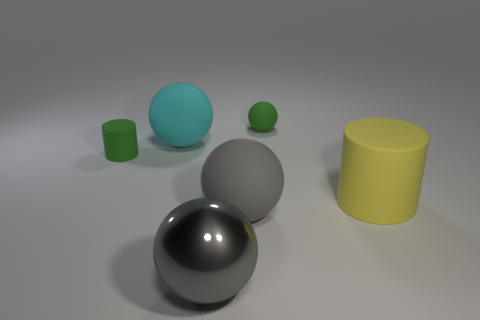What is the shape of the large matte thing that is left of the yellow matte cylinder and in front of the cyan rubber object?
Give a very brief answer. Sphere. There is a large sphere that is behind the cylinder on the left side of the green matte object that is behind the cyan sphere; what color is it?
Make the answer very short. Cyan. Are there fewer metal balls left of the cyan sphere than large rubber balls?
Provide a short and direct response. Yes. There is a big rubber object that is behind the large yellow object; does it have the same shape as the small matte object that is right of the large cyan matte ball?
Your answer should be very brief. Yes. What number of objects are rubber objects that are behind the big cylinder or green matte cylinders?
Your response must be concise. 3. There is a small thing that is the same color as the small cylinder; what is its material?
Offer a very short reply. Rubber. Is there a yellow thing behind the small rubber object on the right side of the green rubber thing to the left of the gray rubber thing?
Offer a very short reply. No. Are there fewer matte balls that are in front of the gray shiny thing than objects to the right of the large yellow object?
Offer a terse response. No. What is the color of the tiny ball that is the same material as the cyan thing?
Your answer should be very brief. Green. What is the color of the large sphere that is behind the small rubber cylinder that is to the left of the cyan thing?
Your response must be concise. Cyan. 